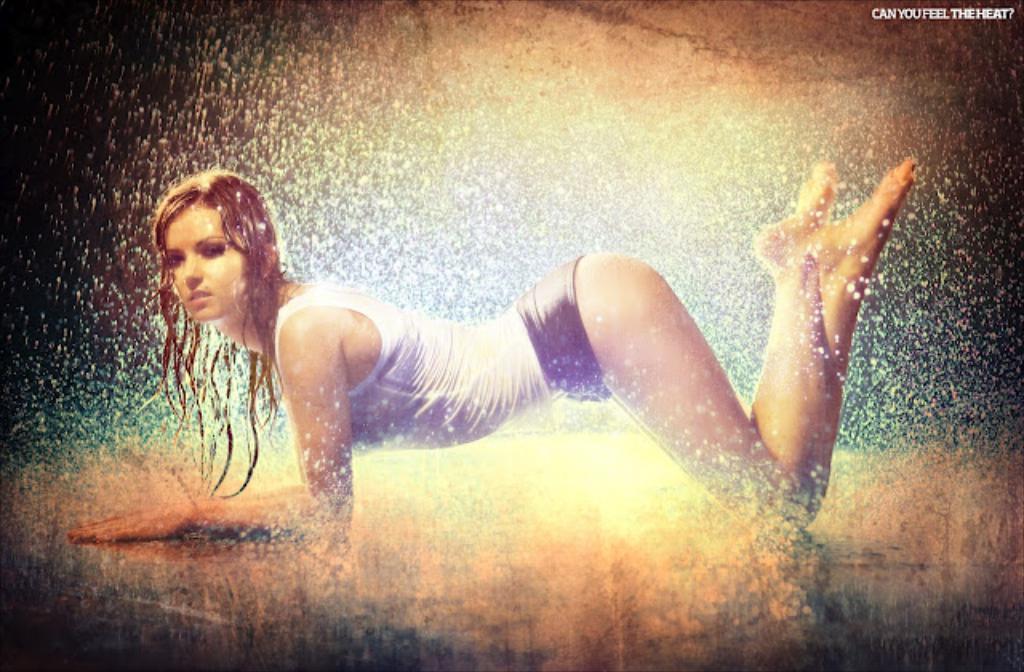Could you give a brief overview of what you see in this image? In this image we can see a woman on the floor and water. 